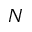<formula> <loc_0><loc_0><loc_500><loc_500>N</formula> 